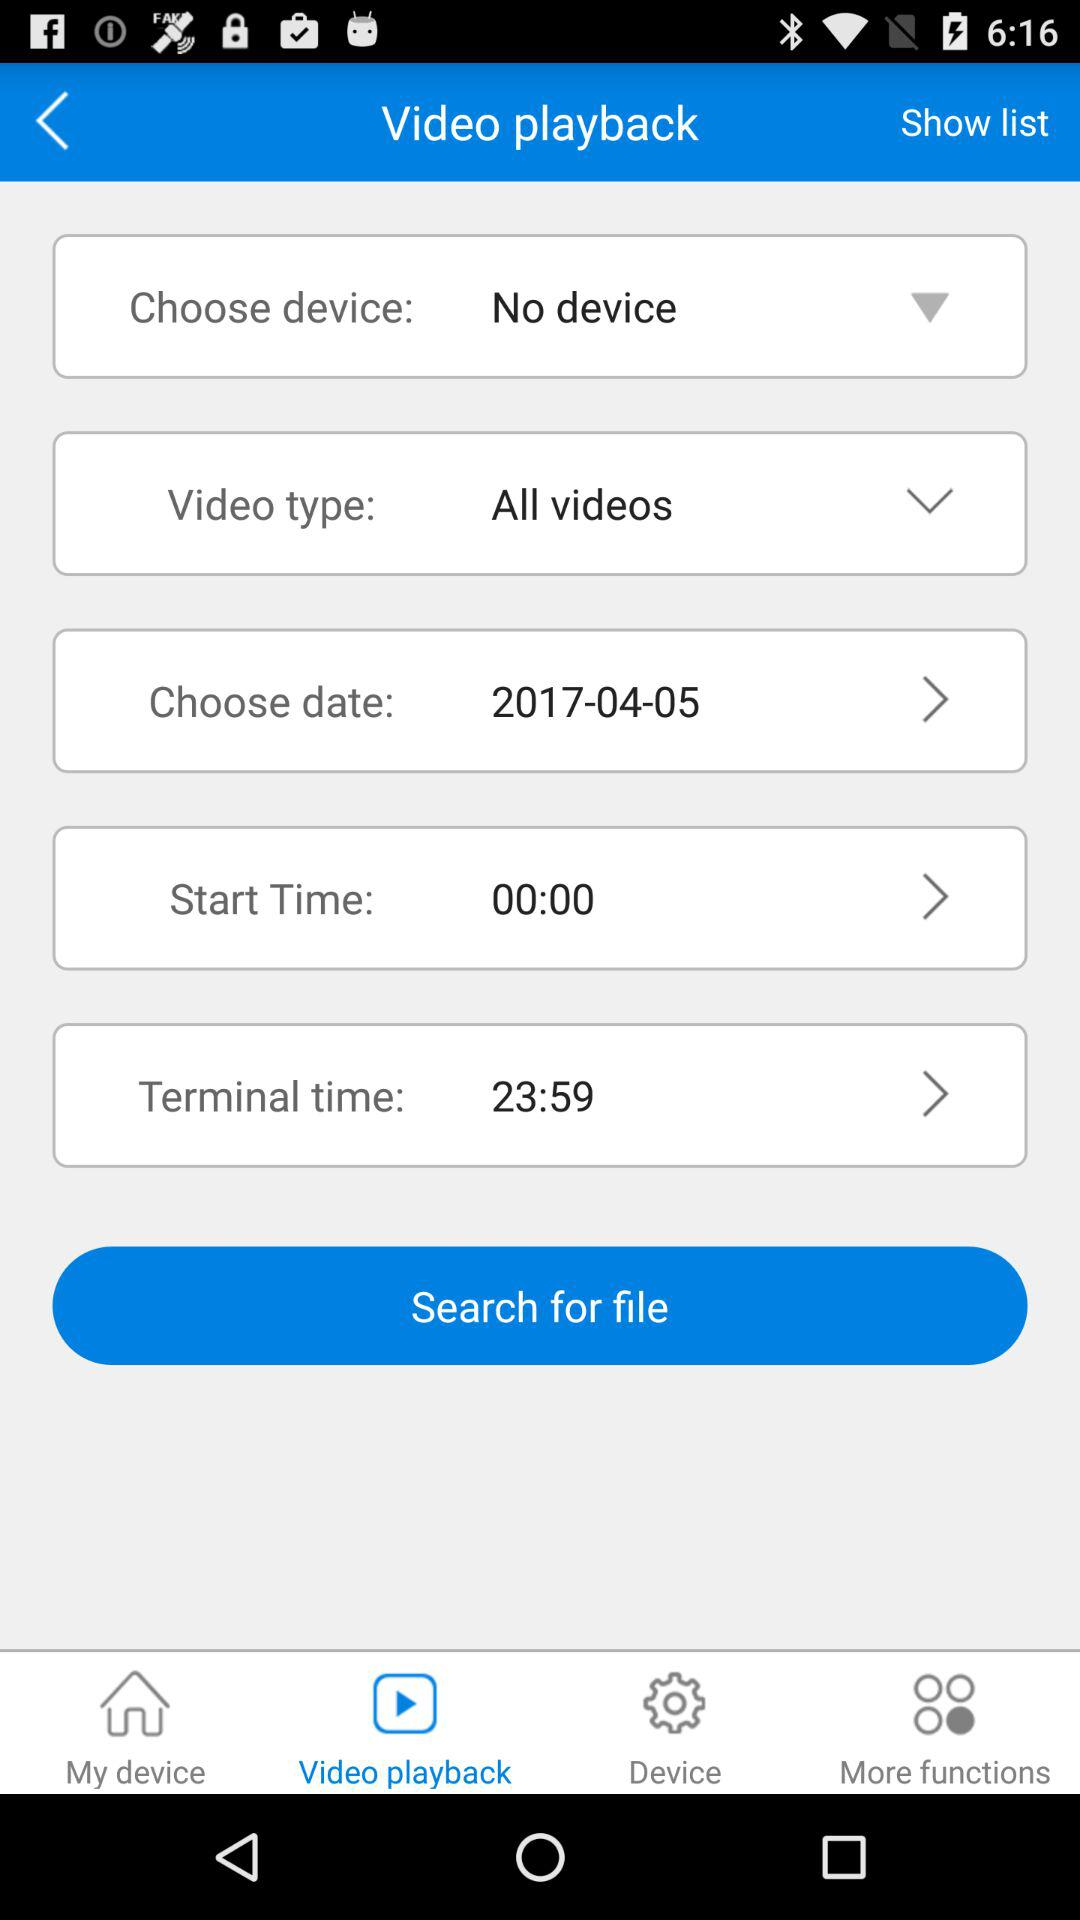What is the selected date? The selected date is 2017-04-05. 